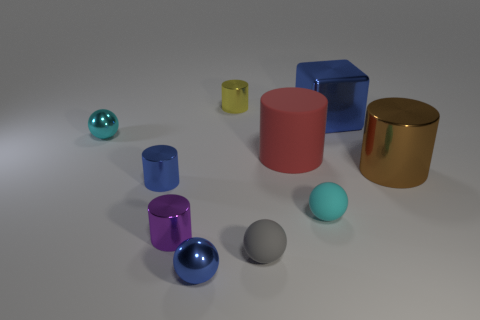How do the textures of these objects differ? The objects possess a variety of textures. Several spheres and the cylinder on the right exhibit a shiny, reflective surface indicative of a metallic texture. The cubes and the remaining cylinder have a more matte finish, suggesting a less reflective material like plastic. 